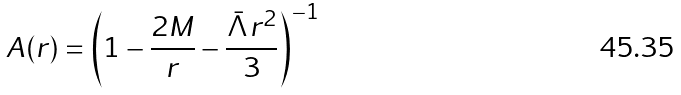Convert formula to latex. <formula><loc_0><loc_0><loc_500><loc_500>A ( r ) = \left ( 1 - \frac { 2 M } { r } - \frac { \bar { \Lambda } r ^ { 2 } } { 3 } \right ) ^ { - 1 }</formula> 